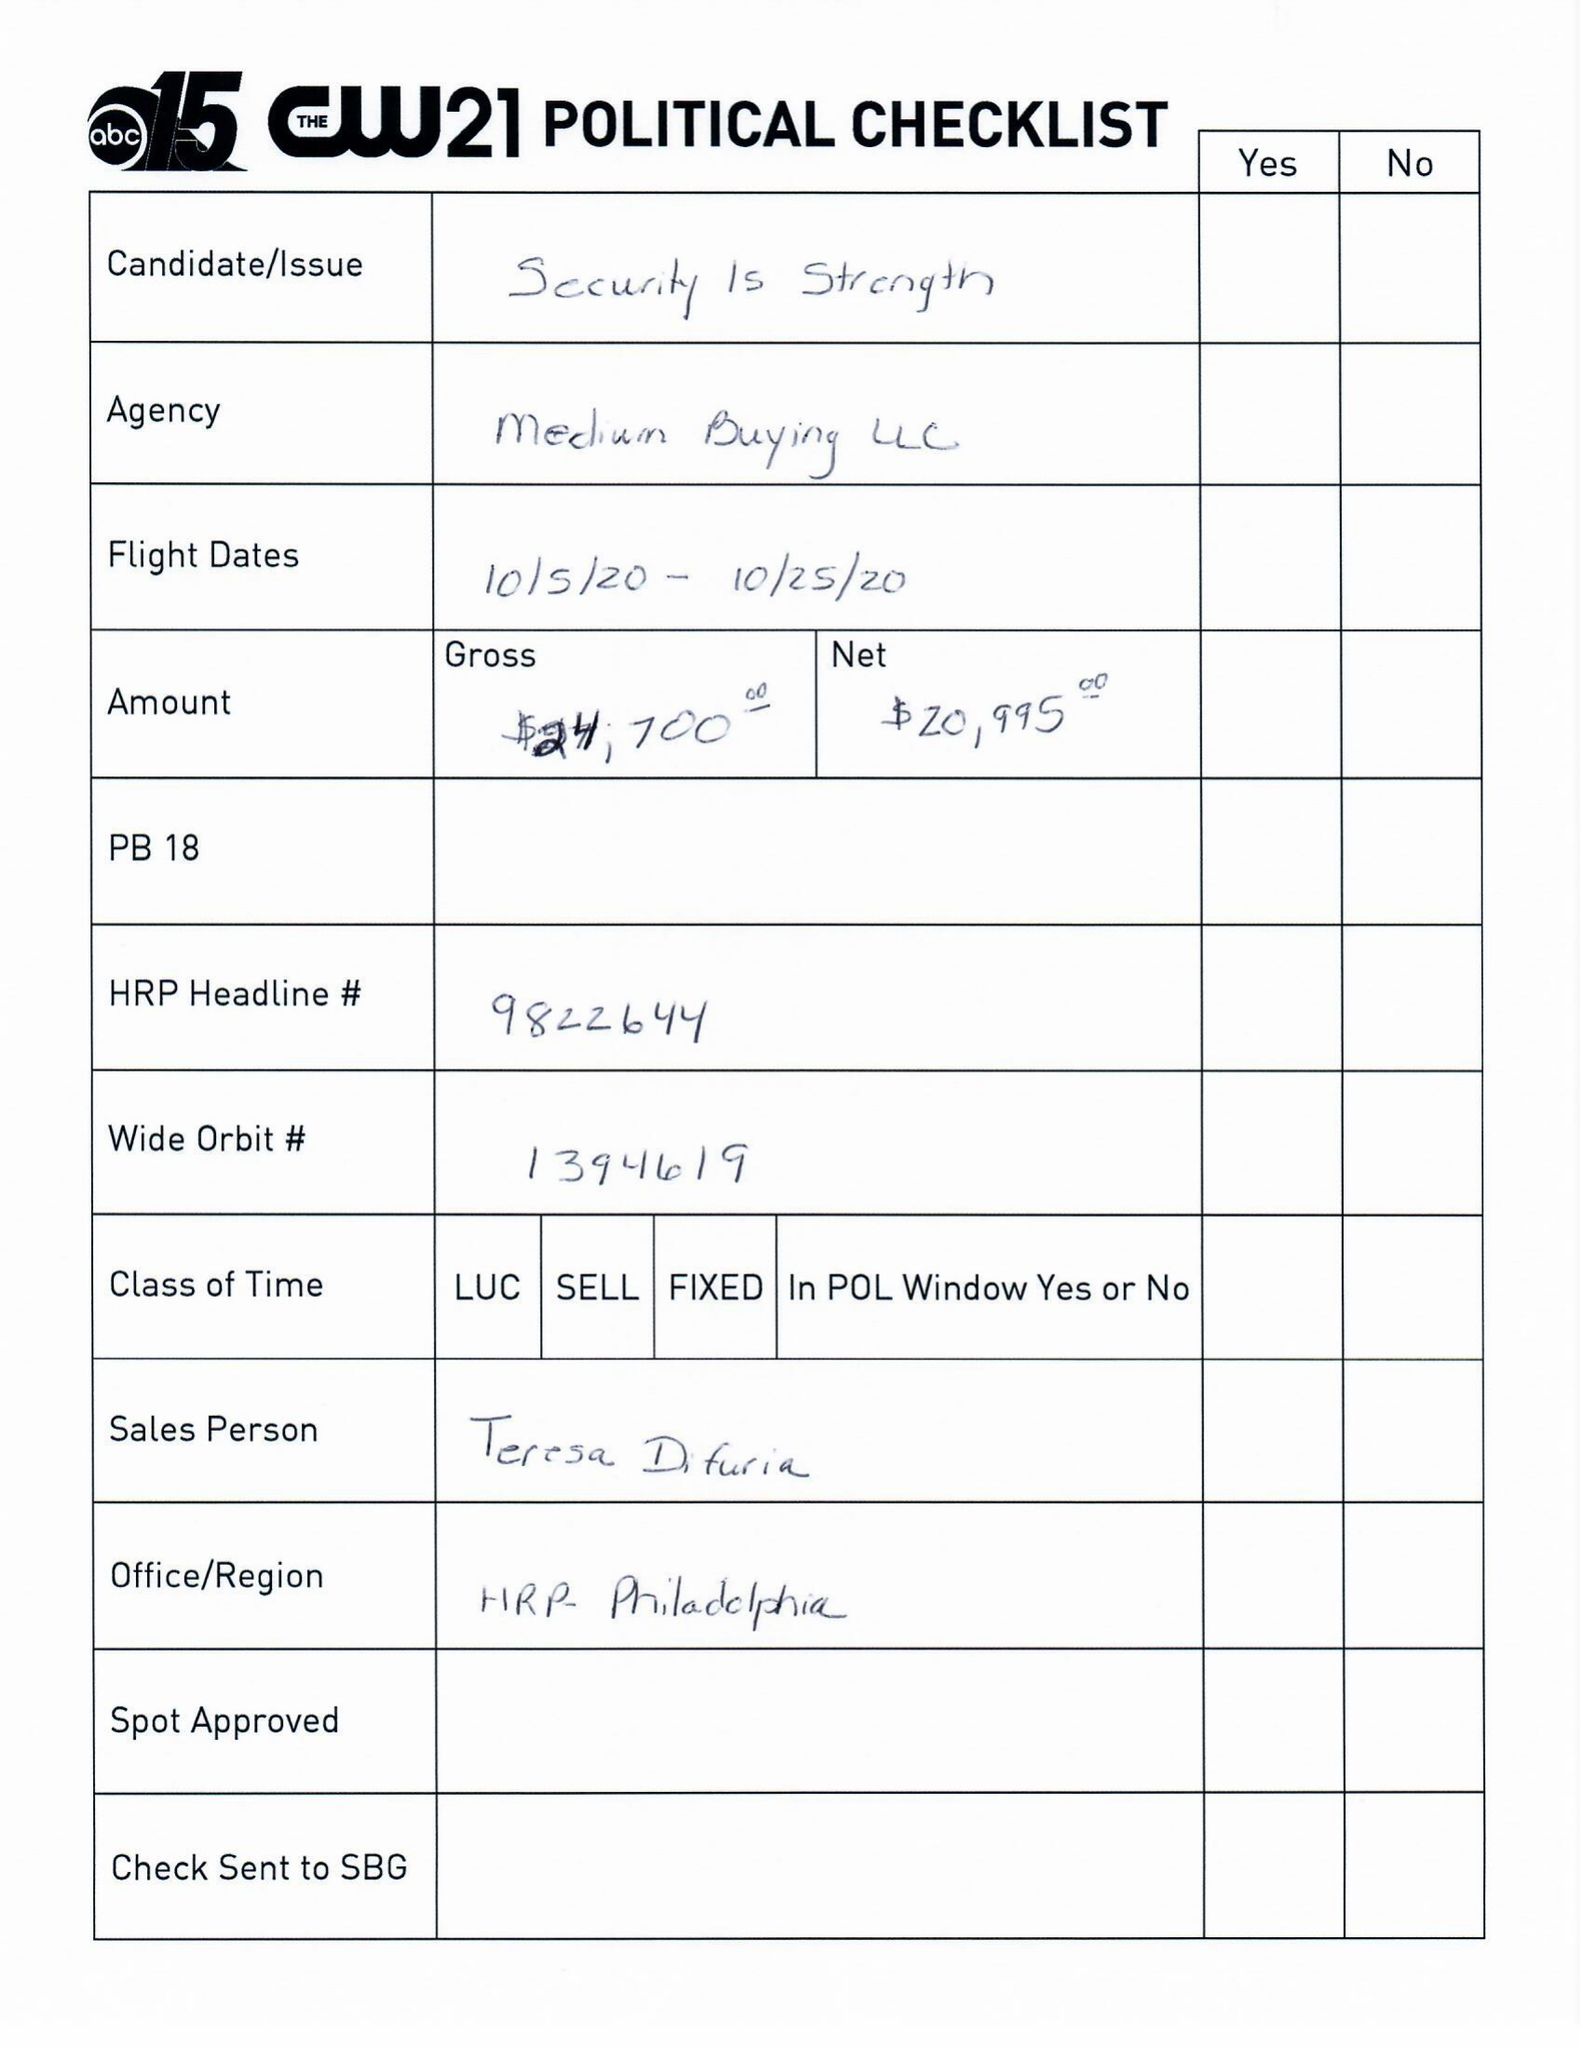What is the value for the flight_to?
Answer the question using a single word or phrase. 10/25/20 